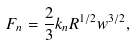Convert formula to latex. <formula><loc_0><loc_0><loc_500><loc_500>F _ { n } = \frac { 2 } { 3 } k _ { n } R ^ { 1 / 2 } w ^ { 3 / 2 } ,</formula> 